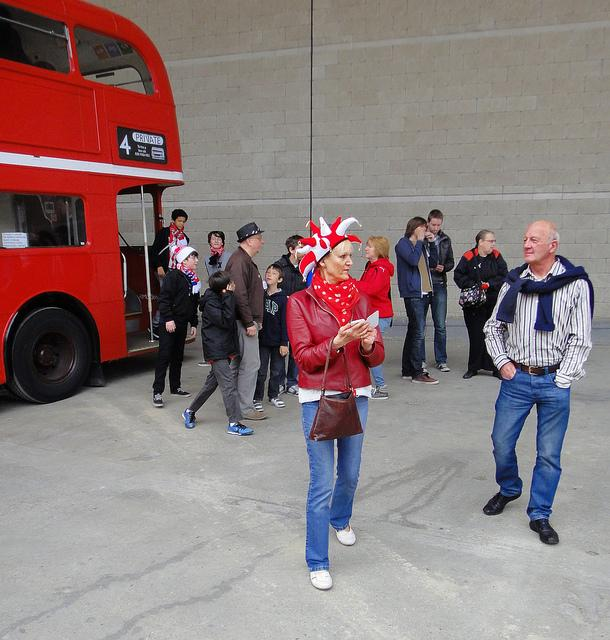What activity do the persons near the bus take part in? touring 